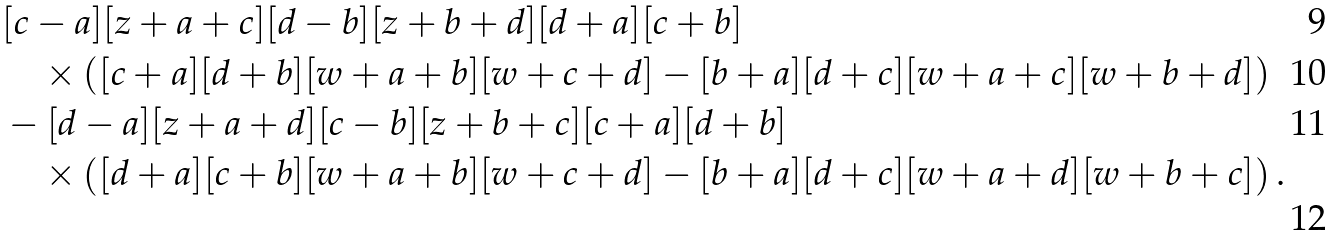Convert formula to latex. <formula><loc_0><loc_0><loc_500><loc_500>& [ c - a ] [ z + a + c ] [ d - b ] [ z + b + d ] [ d + a ] [ c + b ] \\ & \quad \times \left ( [ c + a ] [ d + b ] [ w + a + b ] [ w + c + d ] - [ b + a ] [ d + c ] [ w + a + c ] [ w + b + d ] \right ) \\ & - [ d - a ] [ z + a + d ] [ c - b ] [ z + b + c ] [ c + a ] [ d + b ] \\ & \quad \times \left ( [ d + a ] [ c + b ] [ w + a + b ] [ w + c + d ] - [ b + a ] [ d + c ] [ w + a + d ] [ w + b + c ] \right ) .</formula> 